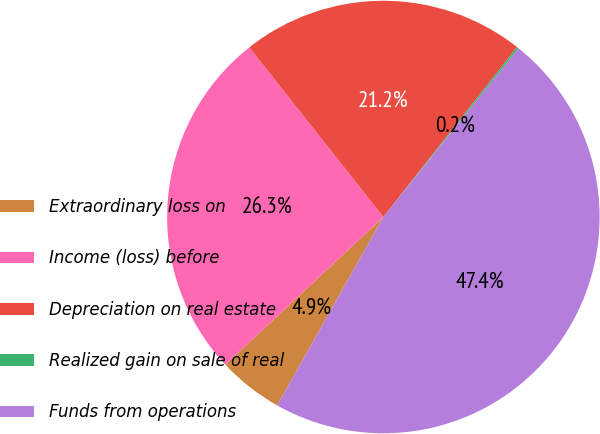<chart> <loc_0><loc_0><loc_500><loc_500><pie_chart><fcel>Extraordinary loss on<fcel>Income (loss) before<fcel>Depreciation on real estate<fcel>Realized gain on sale of real<fcel>Funds from operations<nl><fcel>4.87%<fcel>26.31%<fcel>21.25%<fcel>0.15%<fcel>47.42%<nl></chart> 